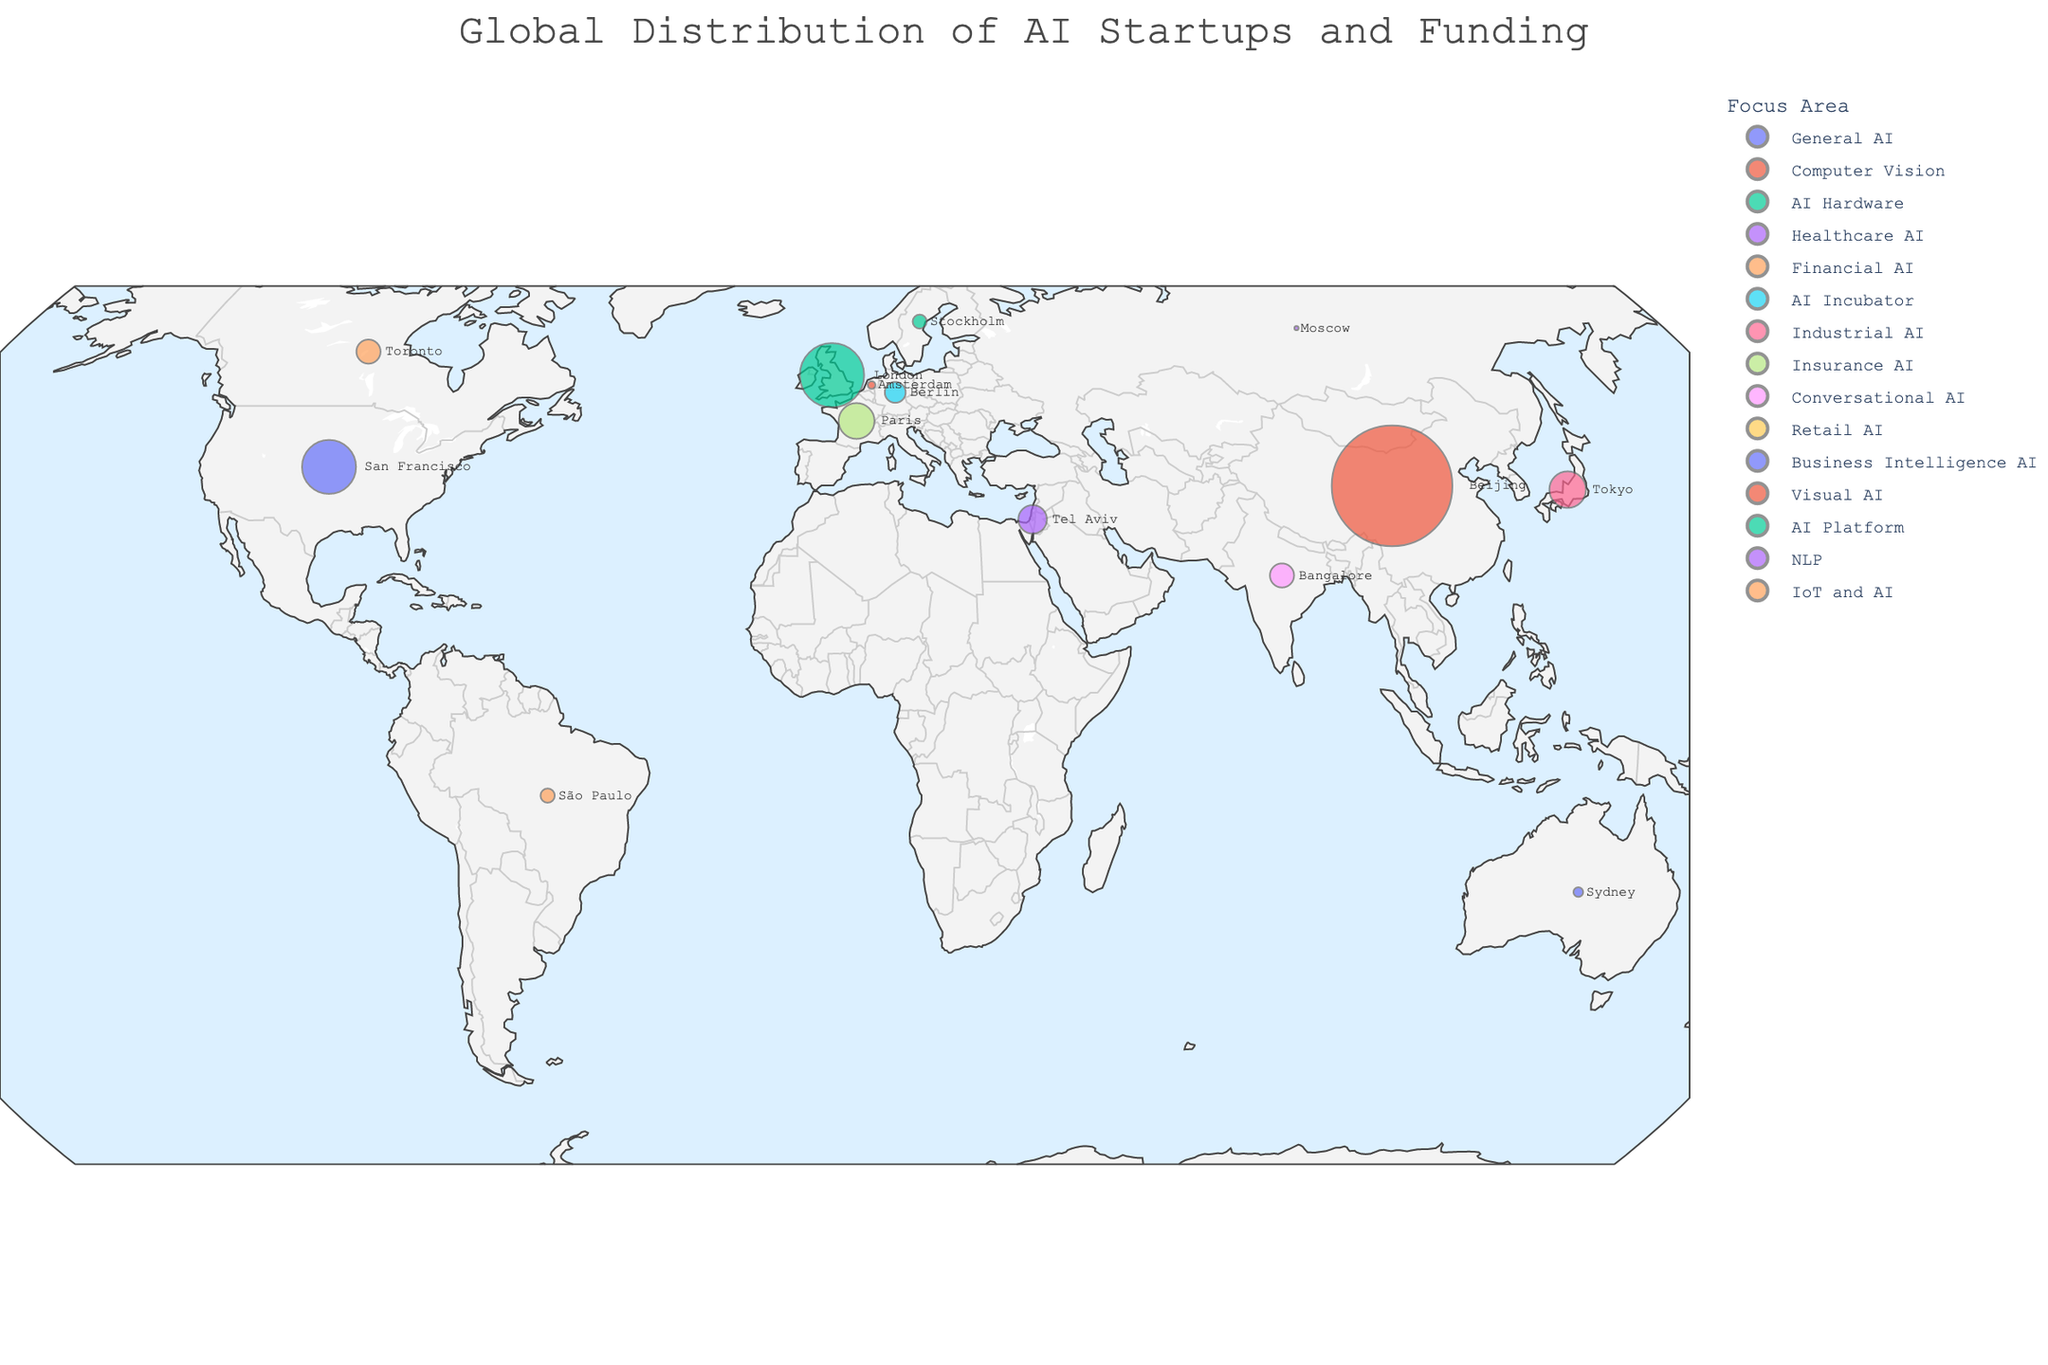What's the title of the plot? The title of the plot is directly mentioned at the top of the figure. You can see it in large font.
Answer: Global Distribution of AI Startups and Funding How many AI startups are represented on this plot? Each data point on the geographic plot represents one AI startup. By counting these data points, you can determine the total number of represented startups.
Answer: 15 Which country has the highest funded AI startup? Look at the size of the data points on the map, the larger points indicate higher funding. Identify the country represented by the largest point.
Answer: China What's the average funding amount of the AI startups in the USA and UK combined? First, find the funding amounts for the USA (500,000,000 USD) and the UK (710,000,000 USD). Combine these values and divide by 2 to get the average. Calculation: (500,000,000 + 710,000,000) / 2.
Answer: 605,000,000 USD Which focus area is most represented on the map? Identify the color code used for different focus areas and count the number of data points for each focus area. The one with the highest count is the most represented.
Answer: AI Platforms and Financial AI Compare the funding amounts of the startups in San Francisco and Beijing, which is greater? Locate the dots representing San Francisco and Beijing. Compare their respective dot sizes or hover over them to get the exact funding amounts.
Answer: Beijing How many AI startups in this plot are located in Europe? Identify the data points located in European countries (e.g., UK, Germany, France, Netherlands, Sweden). Count these points.
Answer: 5 What's the primary funding source for the highest-funded startup? Identify the highest-funded startup by looking at the size of the data points, then refer to the hover information to find out its primary funding source.
Answer: Alibaba Group Which AI startup in this plot focuses on Conversational AI? Use the color coding or hover over the relevant data points to identify which startup is involved in Conversational AI.
Answer: Haptik in Bangalore What is the combined funding amount of the AI startups in Canada and Israel? Find the funding amounts for Canada (100,000,000 USD) and Israel (140,000,000 USD). Add these values to get the combined funding amount.
Answer: 240,000,000 USD 